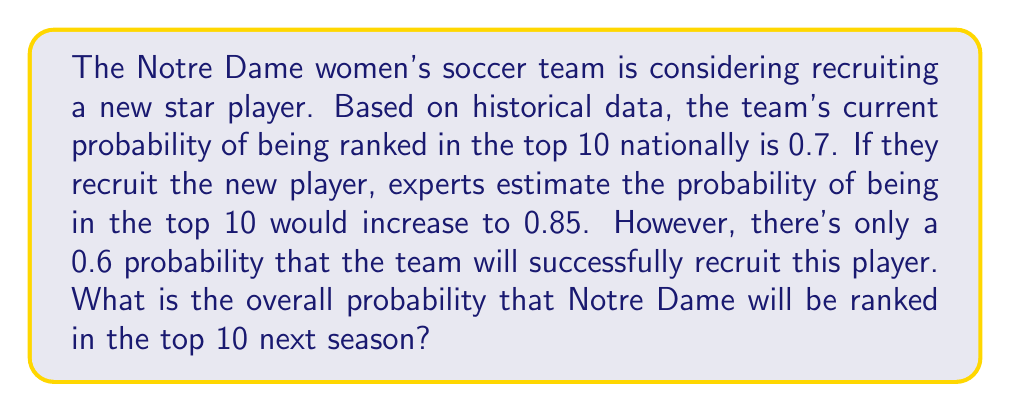Could you help me with this problem? To solve this problem, we'll use the law of total probability. Let's define our events:

A: Notre Dame is ranked in the top 10
B: The new player is successfully recruited

We're given:
$P(A|B) = 0.85$ (probability of being in top 10 if player is recruited)
$P(A|\text{not }B) = 0.7$ (probability of being in top 10 if player is not recruited)
$P(B) = 0.6$ (probability of successfully recruiting the player)

The law of total probability states:

$$P(A) = P(A|B) \cdot P(B) + P(A|\text{not }B) \cdot P(\text{not }B)$$

We know $P(B) = 0.6$, so $P(\text{not }B) = 1 - 0.6 = 0.4$

Substituting our values:

$$P(A) = 0.85 \cdot 0.6 + 0.7 \cdot 0.4$$

$$P(A) = 0.51 + 0.28$$

$$P(A) = 0.79$$

Therefore, the overall probability that Notre Dame will be ranked in the top 10 next season is 0.79 or 79%.
Answer: 0.79 or 79% 